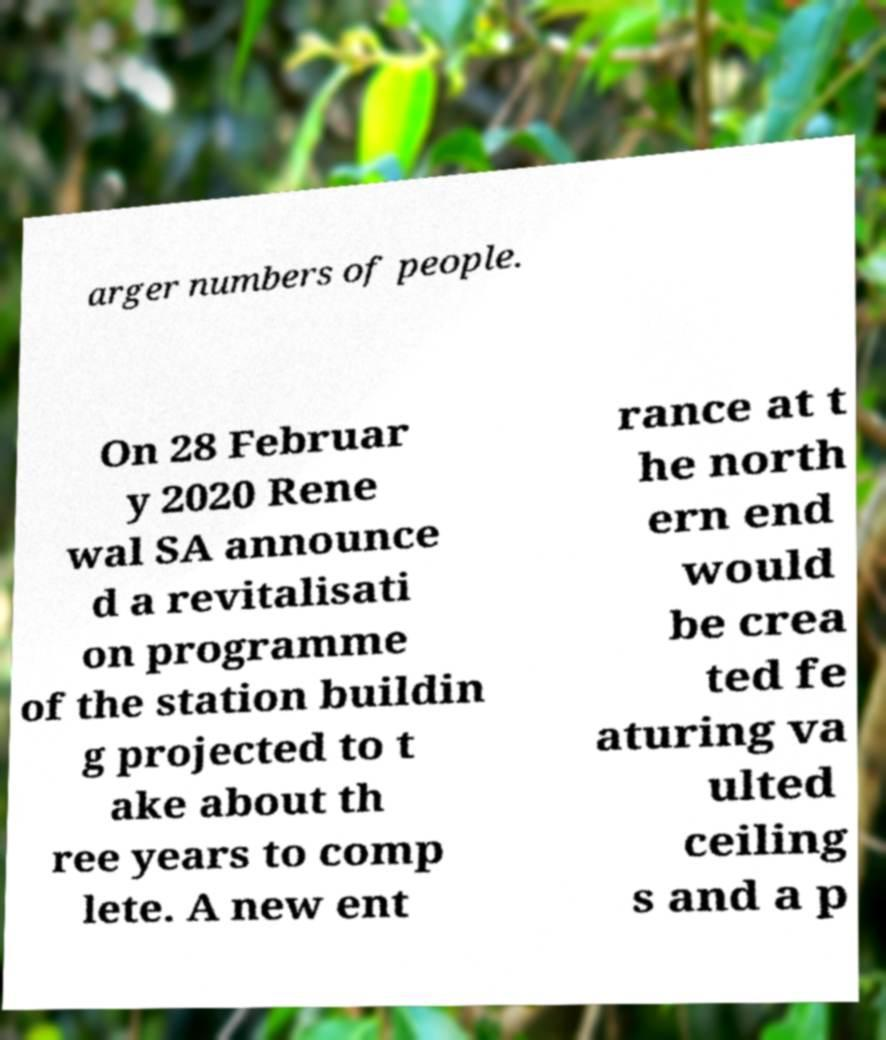Could you assist in decoding the text presented in this image and type it out clearly? arger numbers of people. On 28 Februar y 2020 Rene wal SA announce d a revitalisati on programme of the station buildin g projected to t ake about th ree years to comp lete. A new ent rance at t he north ern end would be crea ted fe aturing va ulted ceiling s and a p 